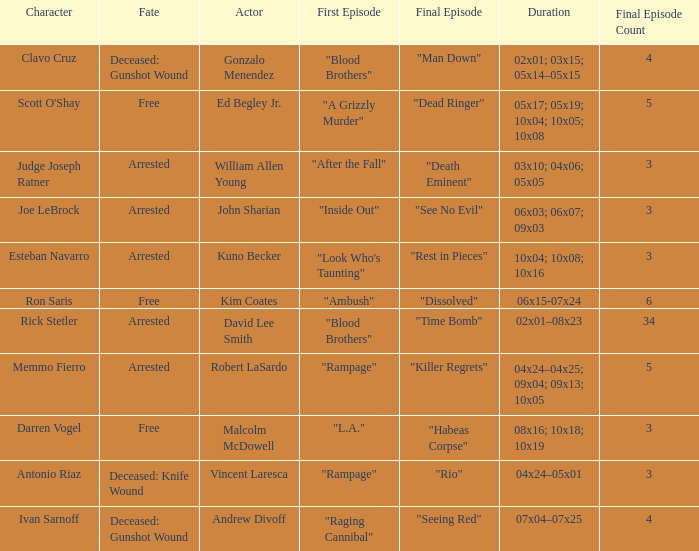What's the first epbeingode with final epbeingode being "rio" "Rampage". 